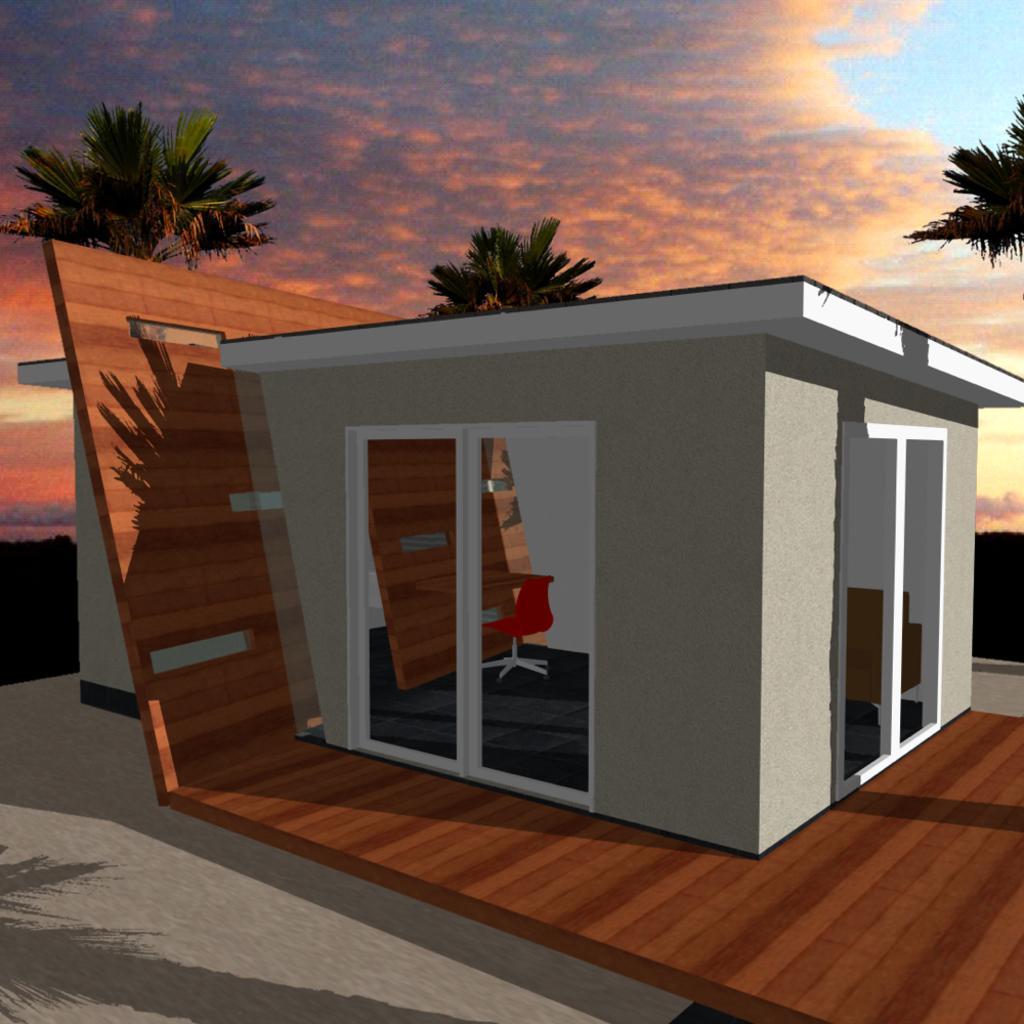Can you describe this image briefly? In this picture I can see graphical image of a house and I can see trees and a blue cloudy sky. 